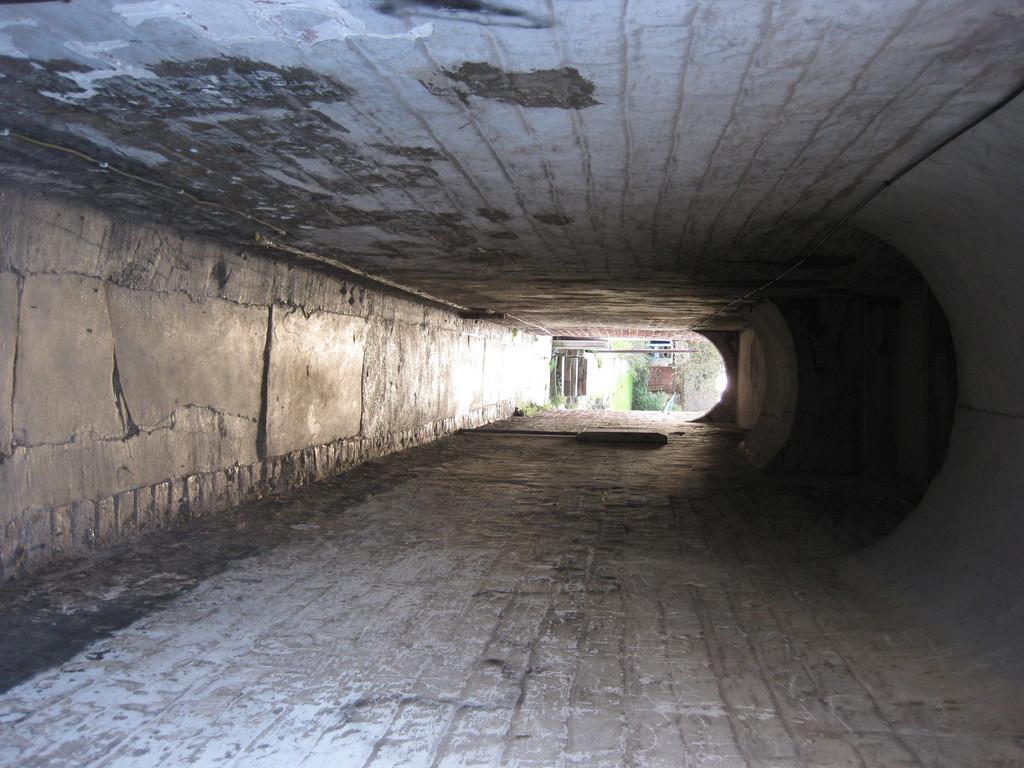In one or two sentences, can you explain what this image depicts? The picture consists of a tunnel are a walkway. At the top it is roof. In the center of the background trees, soil and more objects. 